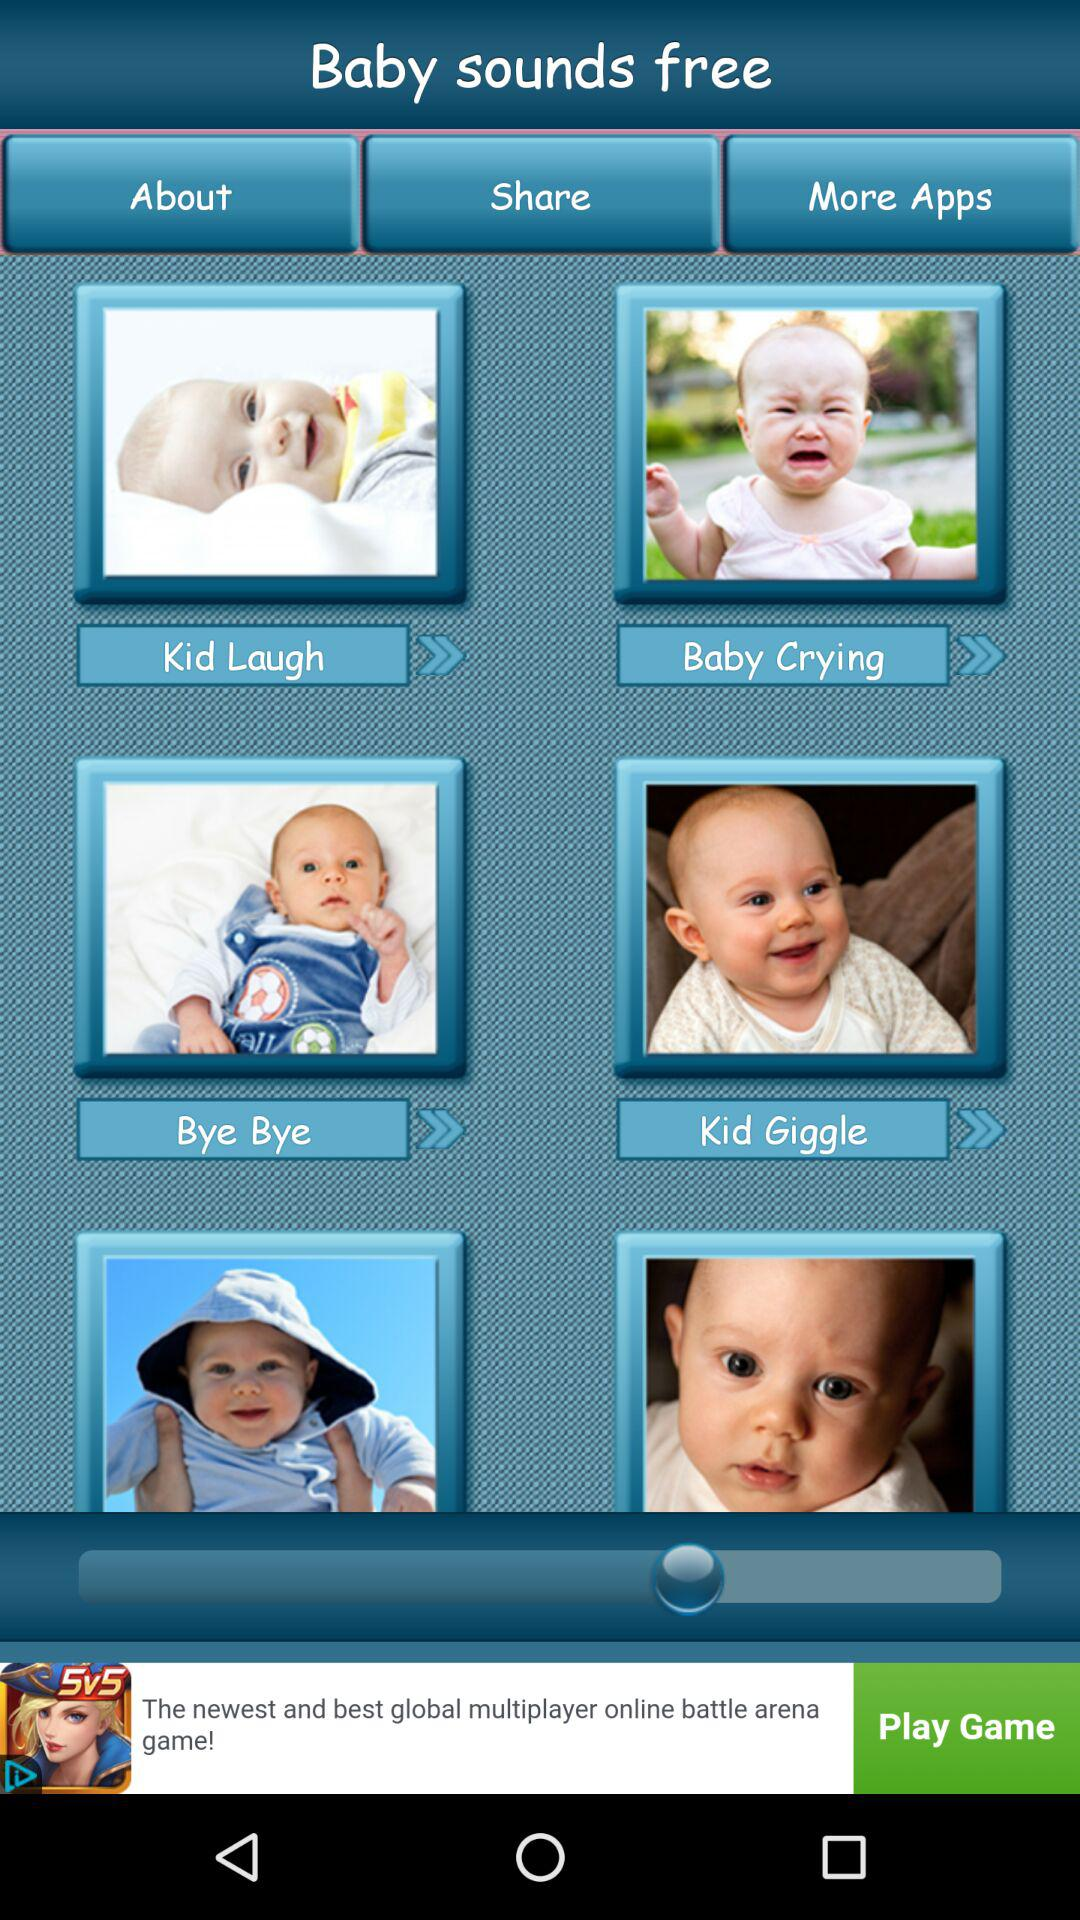How many sounds are there in total?
Answer the question using a single word or phrase. 4 